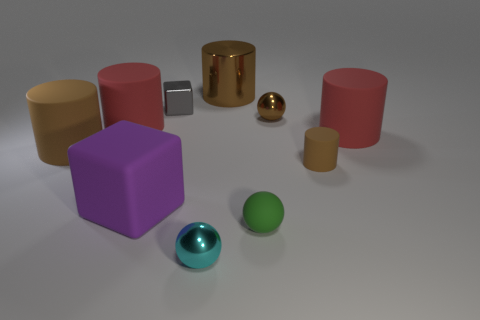Subtract all blue cubes. How many brown cylinders are left? 3 Subtract all spheres. How many objects are left? 7 Add 3 big metal cylinders. How many big metal cylinders exist? 4 Subtract 0 gray cylinders. How many objects are left? 10 Subtract all green things. Subtract all tiny brown metal objects. How many objects are left? 8 Add 5 gray things. How many gray things are left? 6 